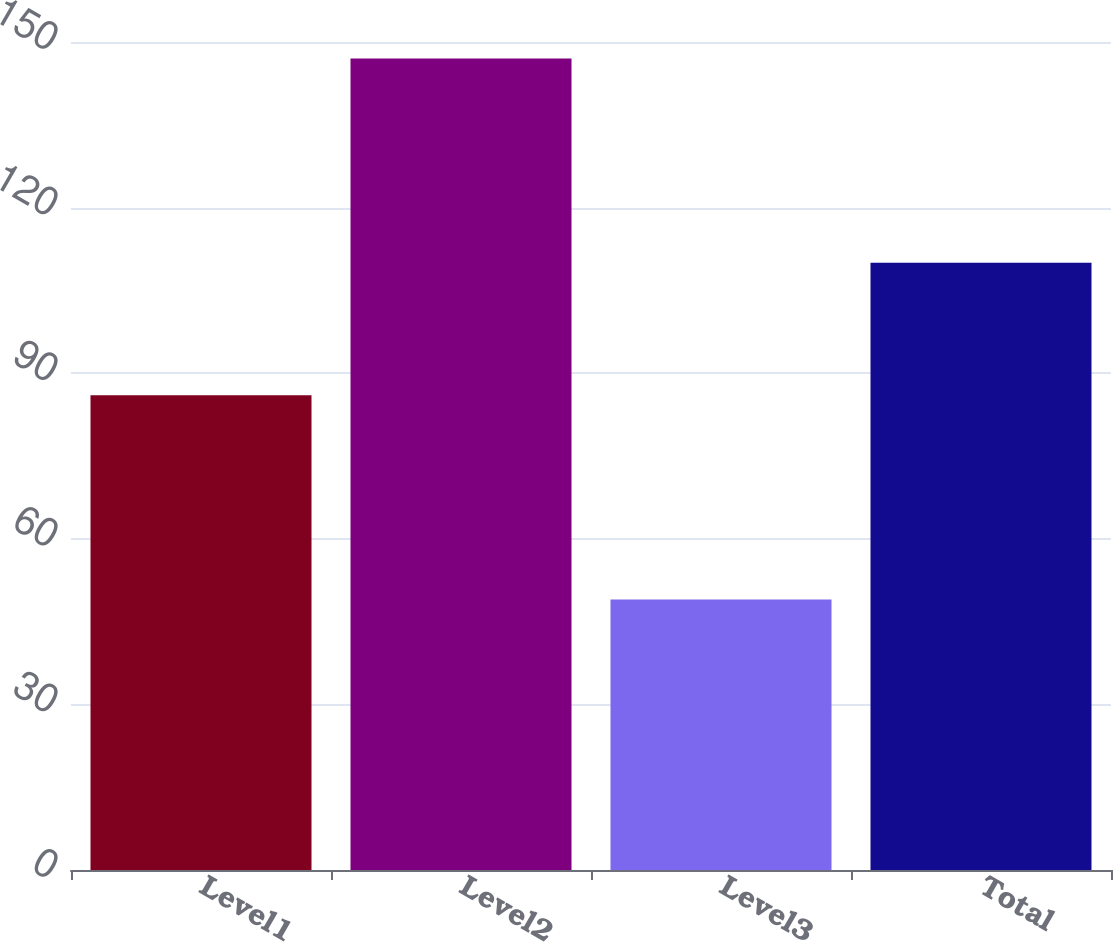Convert chart to OTSL. <chart><loc_0><loc_0><loc_500><loc_500><bar_chart><fcel>Level1<fcel>Level2<fcel>Level3<fcel>Total<nl><fcel>86<fcel>147<fcel>49<fcel>110<nl></chart> 